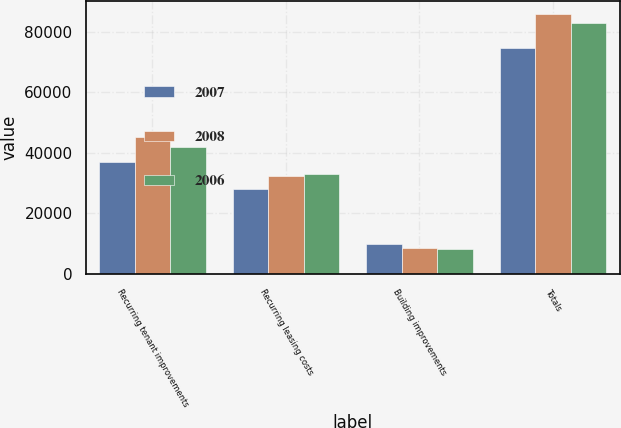Convert chart to OTSL. <chart><loc_0><loc_0><loc_500><loc_500><stacked_bar_chart><ecel><fcel>Recurring tenant improvements<fcel>Recurring leasing costs<fcel>Building improvements<fcel>Totals<nl><fcel>2007<fcel>36885<fcel>28205<fcel>9724<fcel>74814<nl><fcel>2008<fcel>45296<fcel>32238<fcel>8402<fcel>85936<nl><fcel>2006<fcel>41895<fcel>32983<fcel>8122<fcel>83000<nl></chart> 